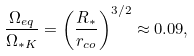<formula> <loc_0><loc_0><loc_500><loc_500>\frac { \Omega _ { e q } } { \Omega _ { * K } } = \left ( \frac { R _ { * } } { r _ { c o } } \right ) ^ { 3 / 2 } \approx 0 . 0 9 ,</formula> 